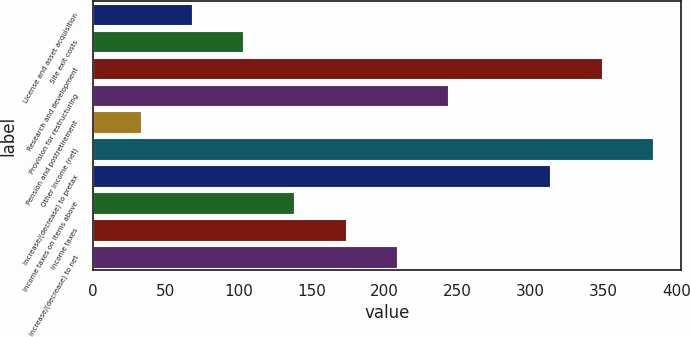Convert chart to OTSL. <chart><loc_0><loc_0><loc_500><loc_500><bar_chart><fcel>License and asset acquisition<fcel>Site exit costs<fcel>Research and development<fcel>Provision for restructuring<fcel>Pension and postretirement<fcel>Other income (net)<fcel>Increase/(decrease) to pretax<fcel>Income taxes on items above<fcel>Income taxes<fcel>Increase/(decrease) to net<nl><fcel>68.1<fcel>103.2<fcel>348.9<fcel>243.6<fcel>33<fcel>384<fcel>313.8<fcel>138.3<fcel>173.4<fcel>208.5<nl></chart> 